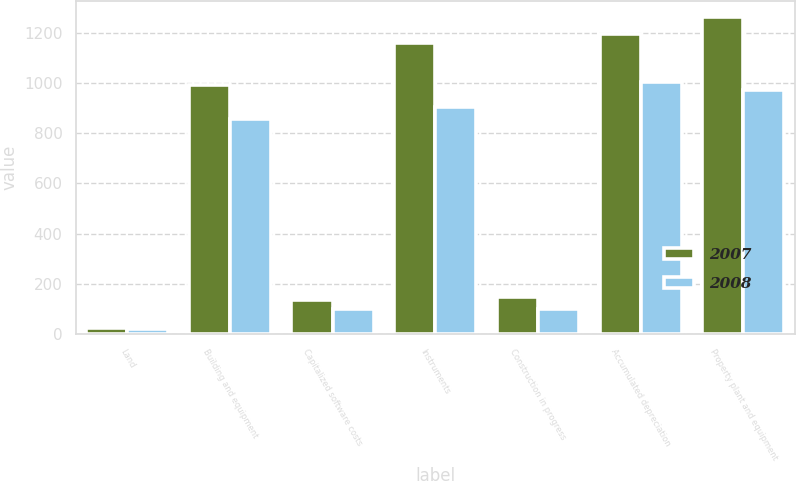Convert chart to OTSL. <chart><loc_0><loc_0><loc_500><loc_500><stacked_bar_chart><ecel><fcel>Land<fcel>Building and equipment<fcel>Capitalized software costs<fcel>Instruments<fcel>Construction in progress<fcel>Accumulated depreciation<fcel>Property plant and equipment<nl><fcel>2007<fcel>21.7<fcel>992.7<fcel>136.7<fcel>1161.7<fcel>149<fcel>1197.7<fcel>1264.1<nl><fcel>2008<fcel>19.4<fcel>855.3<fcel>98.7<fcel>903.8<fcel>98.7<fcel>1004<fcel>971.9<nl></chart> 